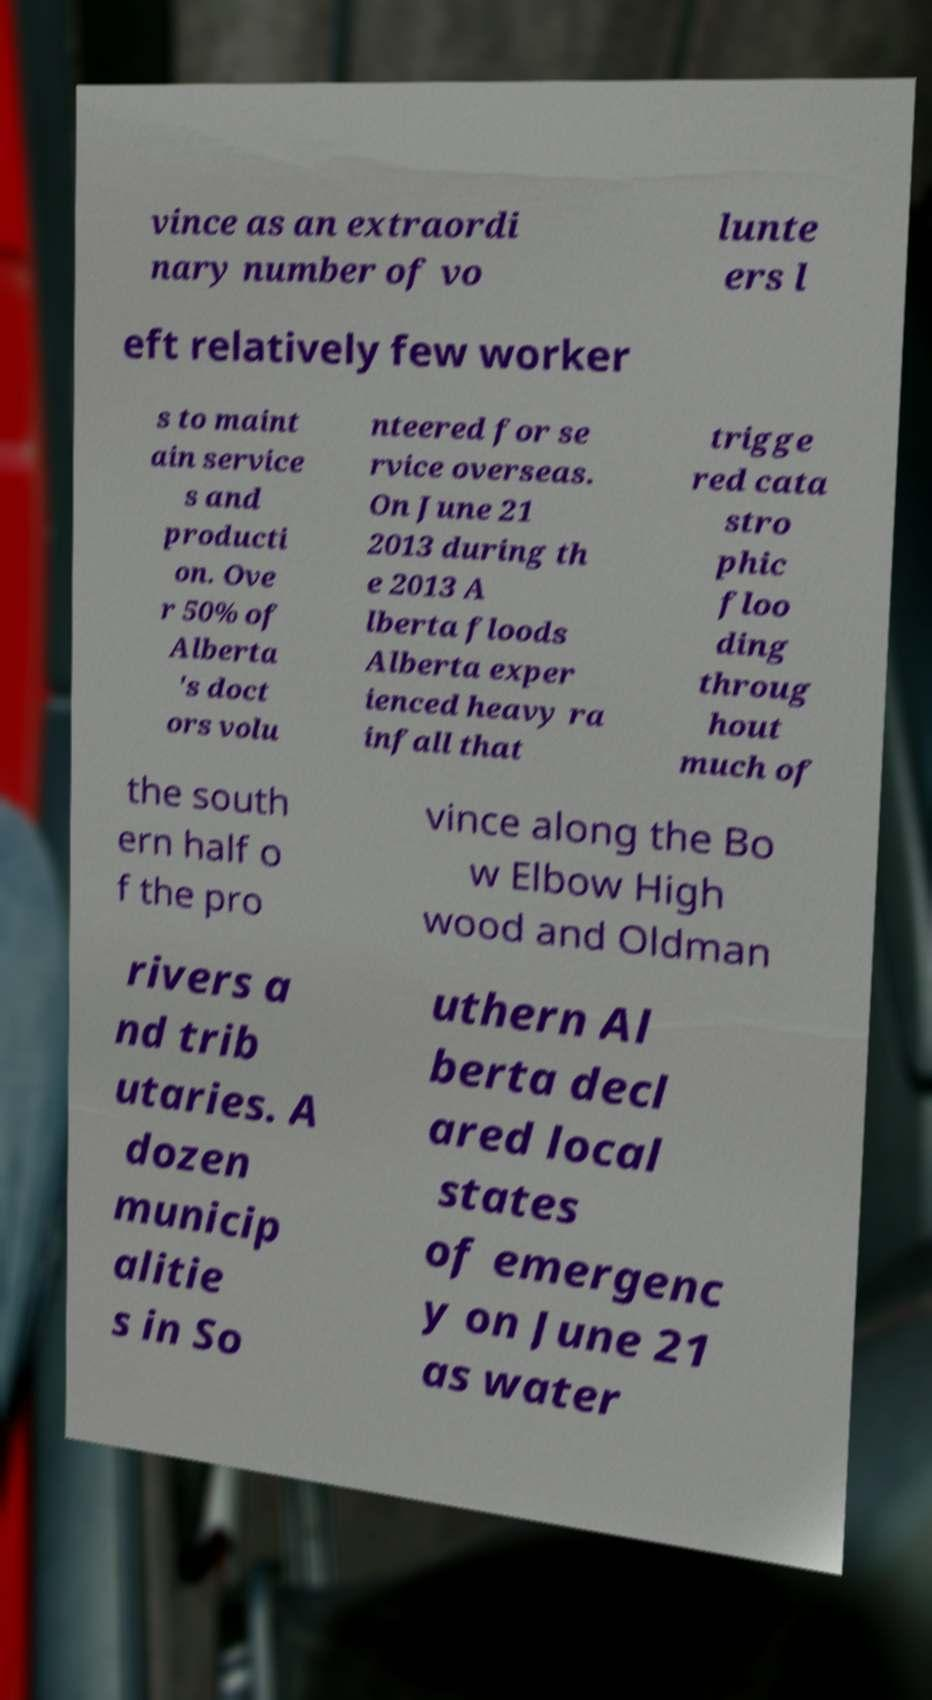For documentation purposes, I need the text within this image transcribed. Could you provide that? vince as an extraordi nary number of vo lunte ers l eft relatively few worker s to maint ain service s and producti on. Ove r 50% of Alberta 's doct ors volu nteered for se rvice overseas. On June 21 2013 during th e 2013 A lberta floods Alberta exper ienced heavy ra infall that trigge red cata stro phic floo ding throug hout much of the south ern half o f the pro vince along the Bo w Elbow High wood and Oldman rivers a nd trib utaries. A dozen municip alitie s in So uthern Al berta decl ared local states of emergenc y on June 21 as water 